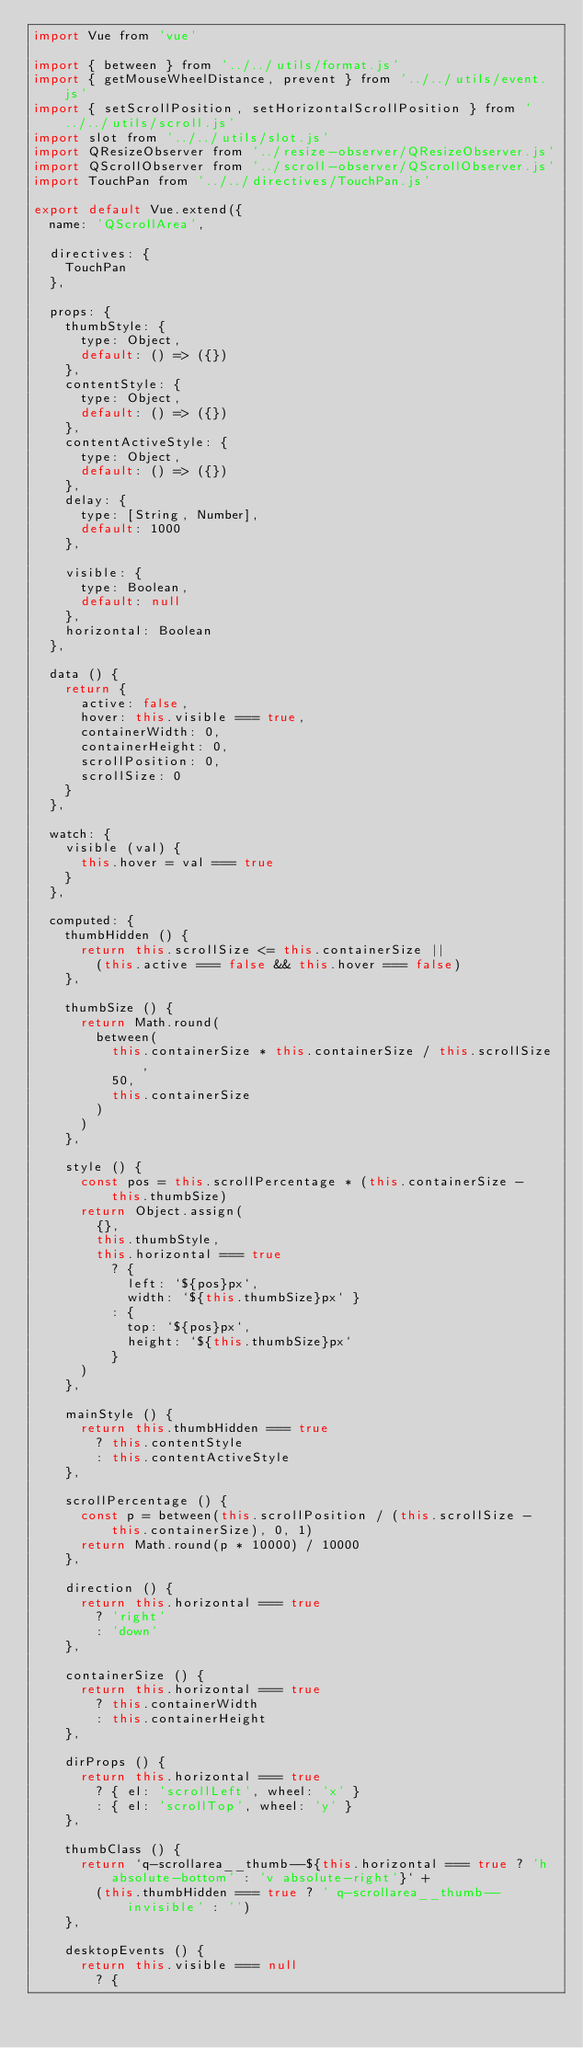<code> <loc_0><loc_0><loc_500><loc_500><_JavaScript_>import Vue from 'vue'

import { between } from '../../utils/format.js'
import { getMouseWheelDistance, prevent } from '../../utils/event.js'
import { setScrollPosition, setHorizontalScrollPosition } from '../../utils/scroll.js'
import slot from '../../utils/slot.js'
import QResizeObserver from '../resize-observer/QResizeObserver.js'
import QScrollObserver from '../scroll-observer/QScrollObserver.js'
import TouchPan from '../../directives/TouchPan.js'

export default Vue.extend({
  name: 'QScrollArea',

  directives: {
    TouchPan
  },

  props: {
    thumbStyle: {
      type: Object,
      default: () => ({})
    },
    contentStyle: {
      type: Object,
      default: () => ({})
    },
    contentActiveStyle: {
      type: Object,
      default: () => ({})
    },
    delay: {
      type: [String, Number],
      default: 1000
    },

    visible: {
      type: Boolean,
      default: null
    },
    horizontal: Boolean
  },

  data () {
    return {
      active: false,
      hover: this.visible === true,
      containerWidth: 0,
      containerHeight: 0,
      scrollPosition: 0,
      scrollSize: 0
    }
  },

  watch: {
    visible (val) {
      this.hover = val === true
    }
  },

  computed: {
    thumbHidden () {
      return this.scrollSize <= this.containerSize ||
        (this.active === false && this.hover === false)
    },

    thumbSize () {
      return Math.round(
        between(
          this.containerSize * this.containerSize / this.scrollSize,
          50,
          this.containerSize
        )
      )
    },

    style () {
      const pos = this.scrollPercentage * (this.containerSize - this.thumbSize)
      return Object.assign(
        {},
        this.thumbStyle,
        this.horizontal === true
          ? {
            left: `${pos}px`,
            width: `${this.thumbSize}px` }
          : {
            top: `${pos}px`,
            height: `${this.thumbSize}px`
          }
      )
    },

    mainStyle () {
      return this.thumbHidden === true
        ? this.contentStyle
        : this.contentActiveStyle
    },

    scrollPercentage () {
      const p = between(this.scrollPosition / (this.scrollSize - this.containerSize), 0, 1)
      return Math.round(p * 10000) / 10000
    },

    direction () {
      return this.horizontal === true
        ? 'right'
        : 'down'
    },

    containerSize () {
      return this.horizontal === true
        ? this.containerWidth
        : this.containerHeight
    },

    dirProps () {
      return this.horizontal === true
        ? { el: 'scrollLeft', wheel: 'x' }
        : { el: 'scrollTop', wheel: 'y' }
    },

    thumbClass () {
      return `q-scrollarea__thumb--${this.horizontal === true ? 'h absolute-bottom' : 'v absolute-right'}` +
        (this.thumbHidden === true ? ' q-scrollarea__thumb--invisible' : '')
    },

    desktopEvents () {
      return this.visible === null
        ? {</code> 